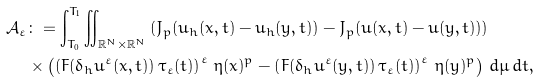<formula> <loc_0><loc_0><loc_500><loc_500>\mathcal { A } _ { \varepsilon } & \colon = \int _ { T _ { 0 } } ^ { T _ { 1 } } \iint _ { \mathbb { R } ^ { N } \times \mathbb { R } ^ { N } } { \left ( J _ { p } ( u _ { h } ( x , t ) - u _ { h } ( y , t ) ) - J _ { p } ( u ( x , t ) - u ( y , t ) ) \right ) } \\ & \times \left ( \left ( F ( \delta _ { h } u ^ { \varepsilon } ( x , t ) ) \, \tau _ { \varepsilon } ( t ) \right ) ^ { \varepsilon } \, \eta ( x ) ^ { p } - \left ( F ( \delta _ { h } u ^ { \varepsilon } ( y , t ) ) \, \tau _ { \varepsilon } ( t ) \right ) ^ { \varepsilon } \, \eta ( y ) ^ { p } \right ) \, d \mu \, d t ,</formula> 